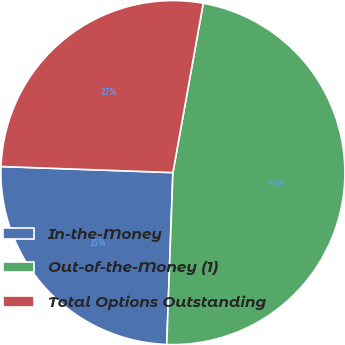Convert chart to OTSL. <chart><loc_0><loc_0><loc_500><loc_500><pie_chart><fcel>In-the-Money<fcel>Out-of-the-Money (1)<fcel>Total Options Outstanding<nl><fcel>24.99%<fcel>47.75%<fcel>27.26%<nl></chart> 